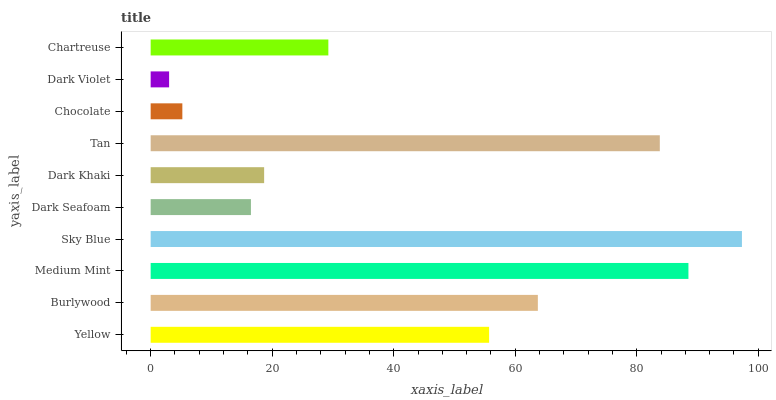Is Dark Violet the minimum?
Answer yes or no. Yes. Is Sky Blue the maximum?
Answer yes or no. Yes. Is Burlywood the minimum?
Answer yes or no. No. Is Burlywood the maximum?
Answer yes or no. No. Is Burlywood greater than Yellow?
Answer yes or no. Yes. Is Yellow less than Burlywood?
Answer yes or no. Yes. Is Yellow greater than Burlywood?
Answer yes or no. No. Is Burlywood less than Yellow?
Answer yes or no. No. Is Yellow the high median?
Answer yes or no. Yes. Is Chartreuse the low median?
Answer yes or no. Yes. Is Sky Blue the high median?
Answer yes or no. No. Is Dark Khaki the low median?
Answer yes or no. No. 